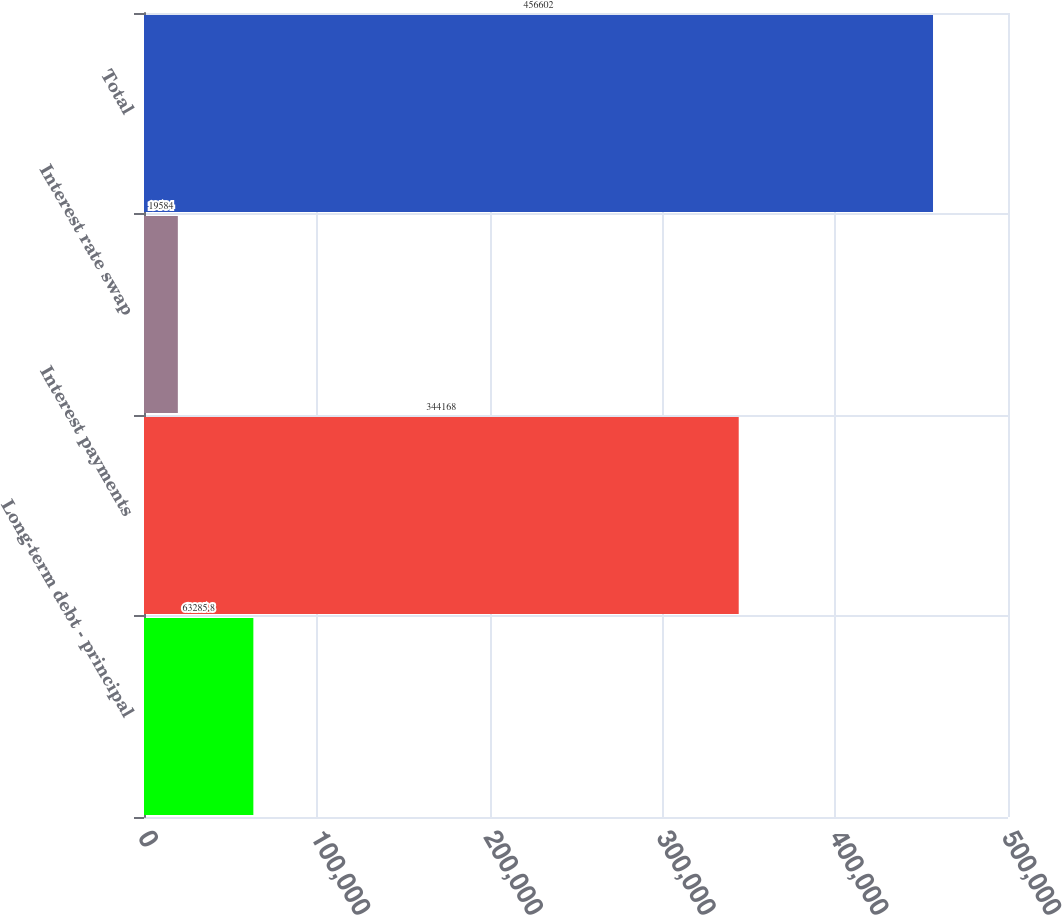Convert chart to OTSL. <chart><loc_0><loc_0><loc_500><loc_500><bar_chart><fcel>Long-term debt - principal<fcel>Interest payments<fcel>Interest rate swap<fcel>Total<nl><fcel>63285.8<fcel>344168<fcel>19584<fcel>456602<nl></chart> 